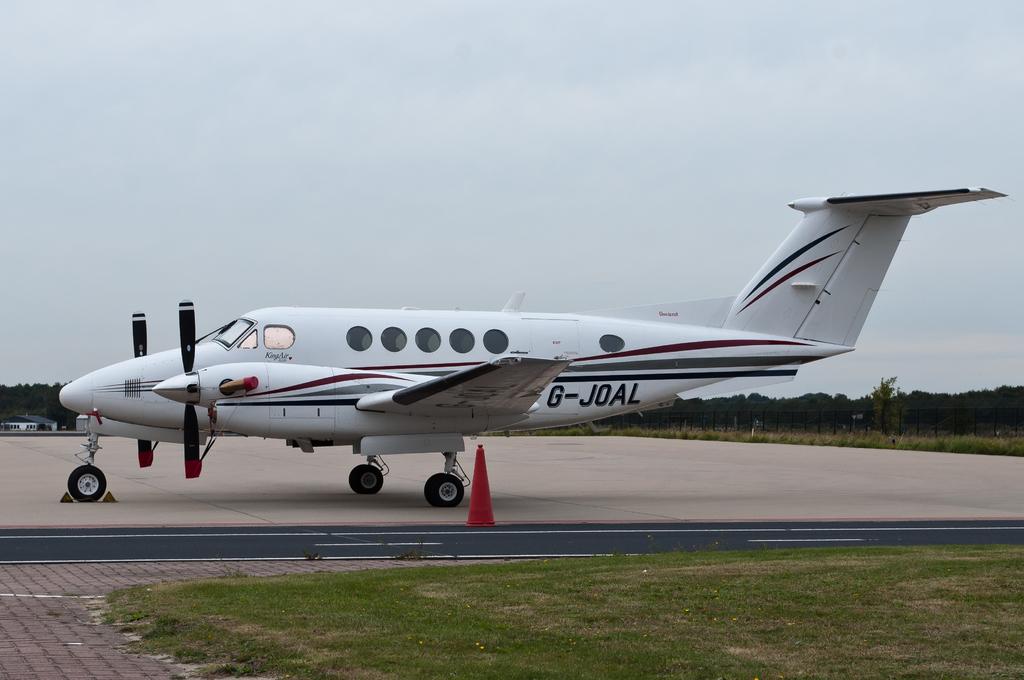What type of plane is this?
Make the answer very short. G-joal. 